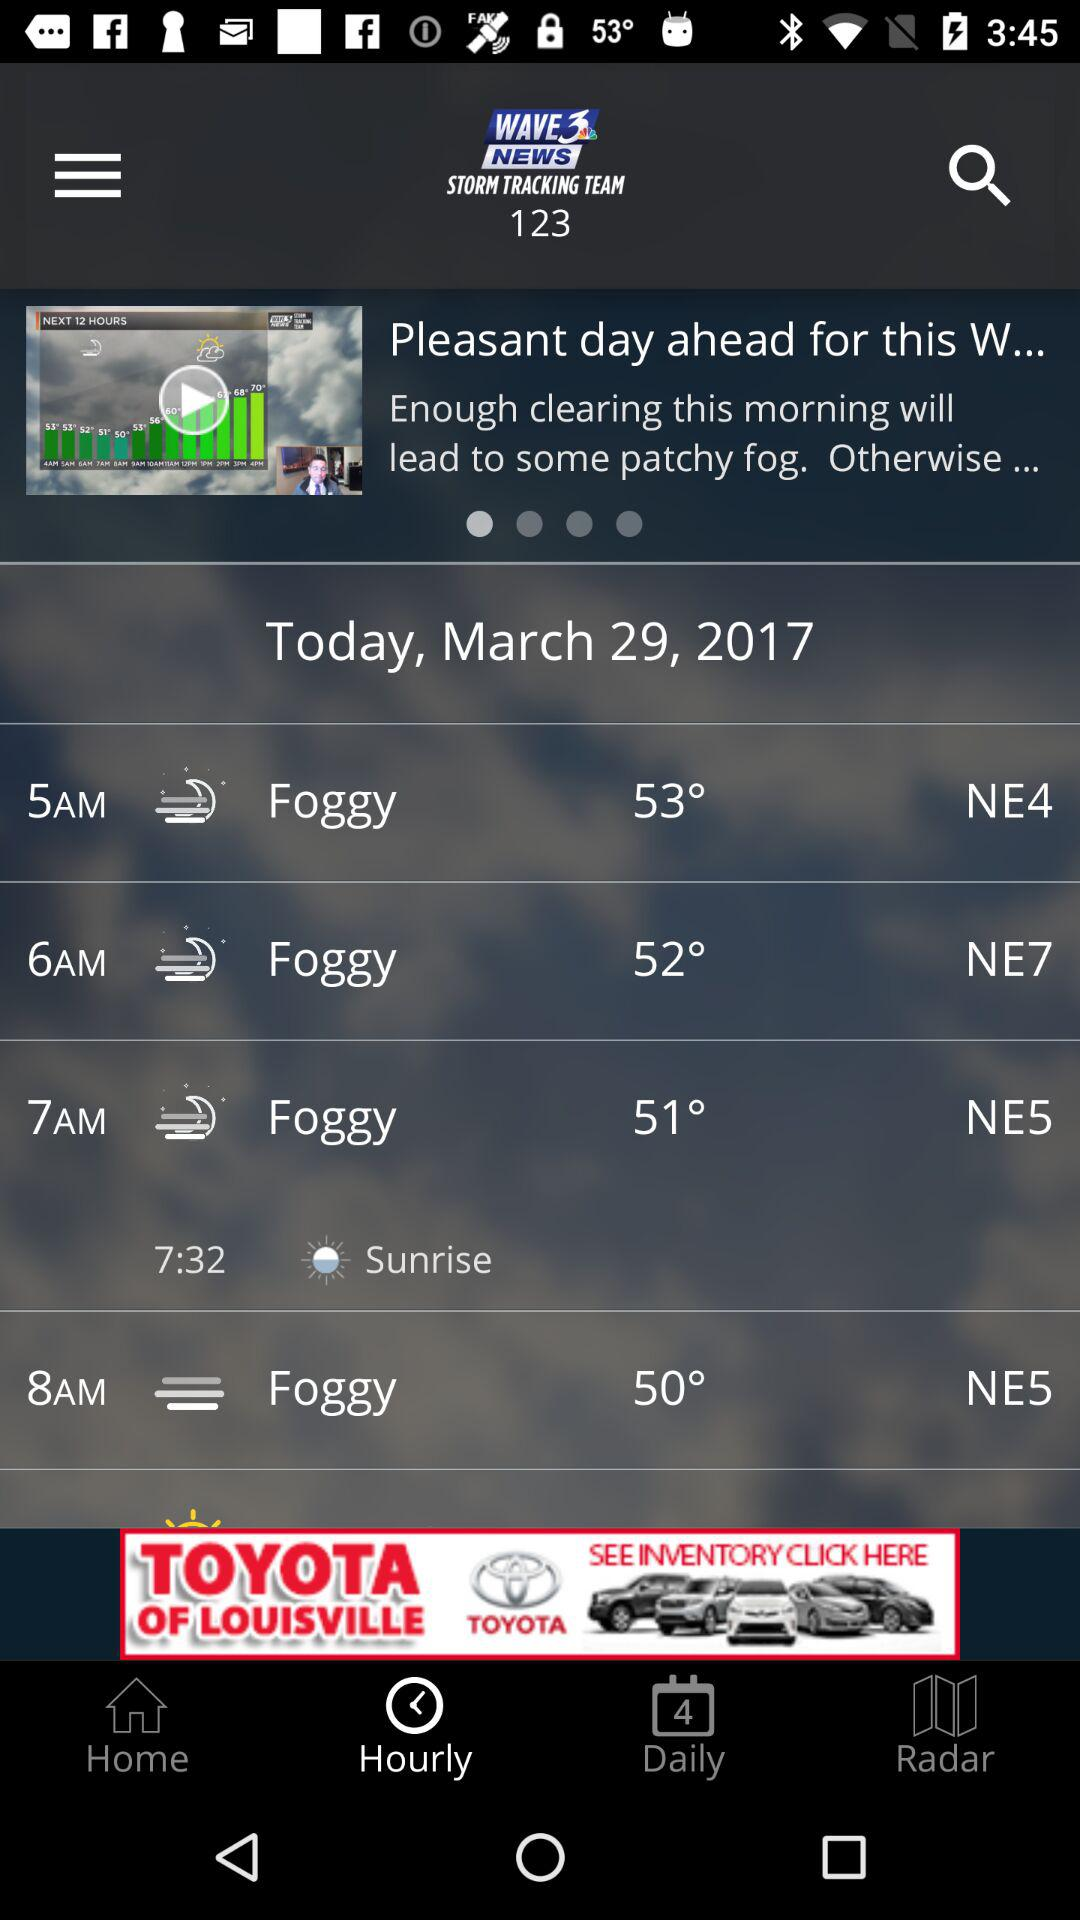How many degrees Fahrenheit is the temperature at 8 am?
Answer the question using a single word or phrase. 50° 